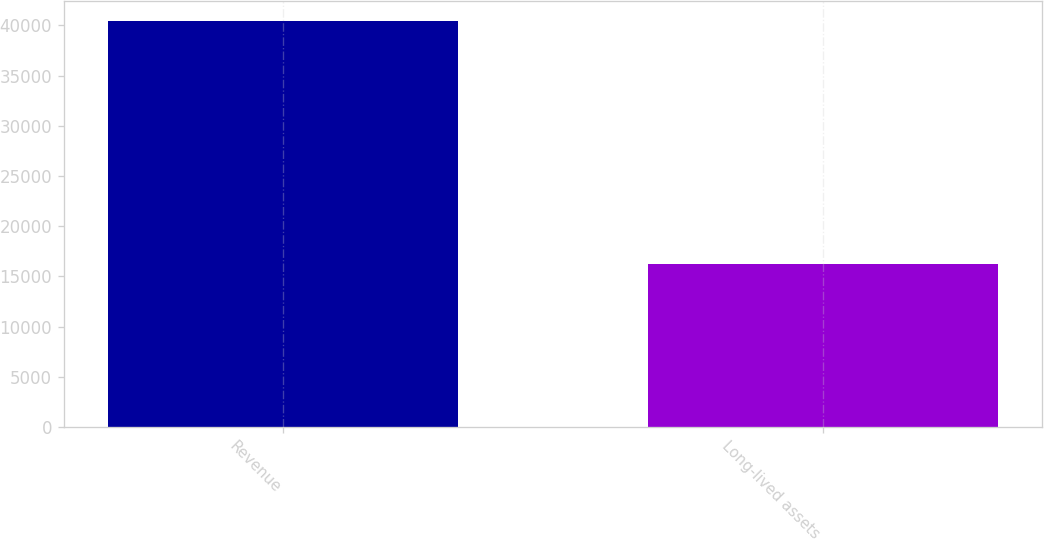Convert chart. <chart><loc_0><loc_0><loc_500><loc_500><bar_chart><fcel>Revenue<fcel>Long-lived assets<nl><fcel>40428<fcel>16262<nl></chart> 